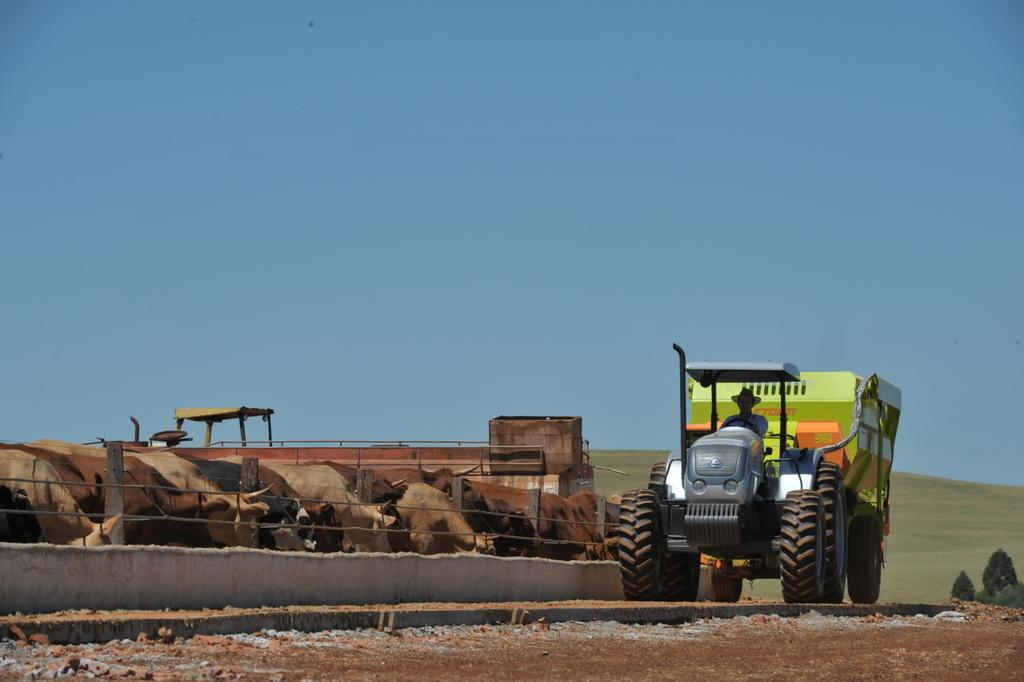What is the main subject of the image? The main subject of the image is a vehicle on the road. Can you describe the surroundings of the vehicle? There is a fencing wall beside the vehicle. What type of quill is being used to write on the fencing wall in the image? There is no quill or writing present on the fencing wall in the image. How many pigs can be seen running alongside the vehicle in the image? There are no pigs present in the image; it only features a vehicle and a fencing wall. 